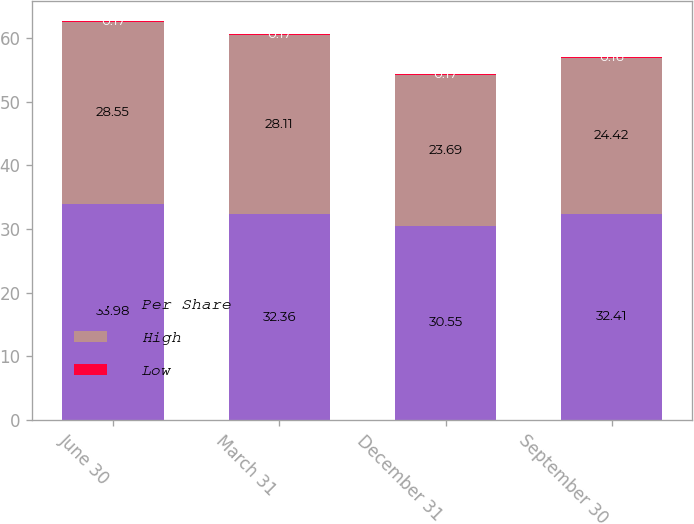Convert chart. <chart><loc_0><loc_0><loc_500><loc_500><stacked_bar_chart><ecel><fcel>June 30<fcel>March 31<fcel>December 31<fcel>September 30<nl><fcel>Per Share<fcel>33.98<fcel>32.36<fcel>30.55<fcel>32.41<nl><fcel>High<fcel>28.55<fcel>28.11<fcel>23.69<fcel>24.42<nl><fcel>Low<fcel>0.17<fcel>0.17<fcel>0.17<fcel>0.16<nl></chart> 